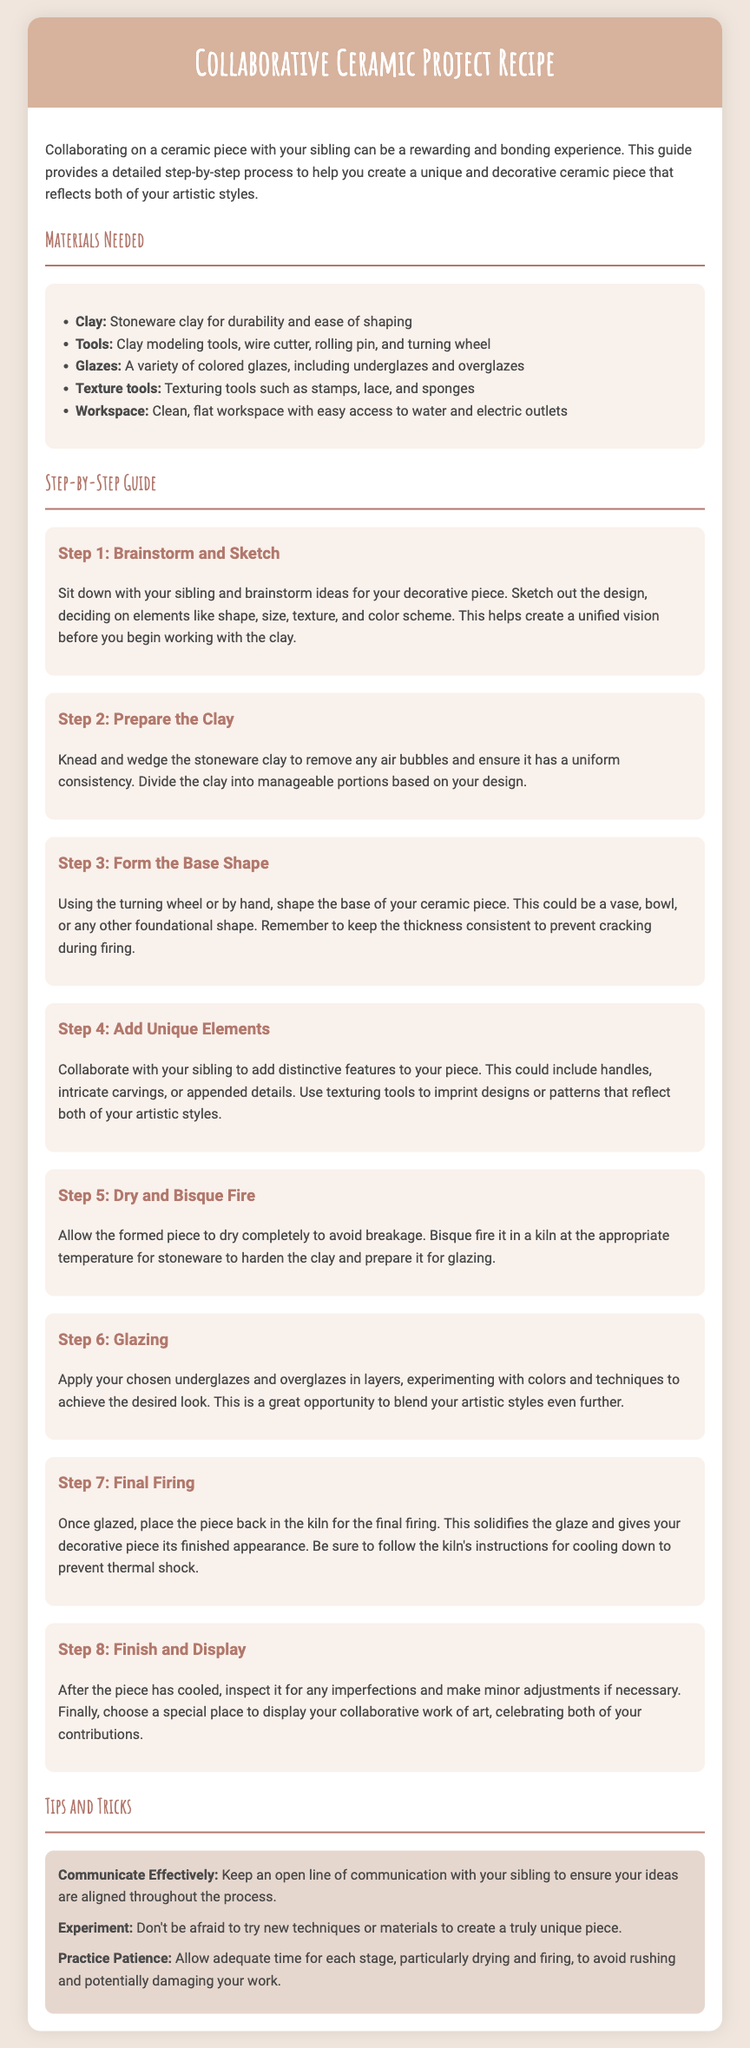What type of clay is recommended? The document specifies "Stoneware clay for durability and ease of shaping" as the recommended type of clay.
Answer: Stoneware What is the first step in the collaborative project? The first step detailed in the document is to "Sit down with your sibling and brainstorm ideas."
Answer: Brainstorm and Sketch How many steps are in the guide? The document outlines a total of eight steps in the guide for the collaborative ceramic project.
Answer: Eight Which tools are mentioned for shaping the clay? The document mentions "Clay modeling tools, wire cutter, rolling pin, and turning wheel" for shaping the clay.
Answer: Clay modeling tools, wire cutter, rolling pin, turning wheel What should you do after glazing the piece? After glazing, the document advises placing the piece back in the kiln for the final firing.
Answer: Final firing What color is the header background? The background color of the header is specified in the document as "#d7b29d."
Answer: #d7b29d What is a suggested tip for the collaborative process? The document suggests "Keep an open line of communication with your sibling" as a helpful tip.
Answer: Communicate Effectively What should the workspace have easy access to? The document indicates that the workspace should have "easy access to water and electric outlets."
Answer: Water and electric outlets 